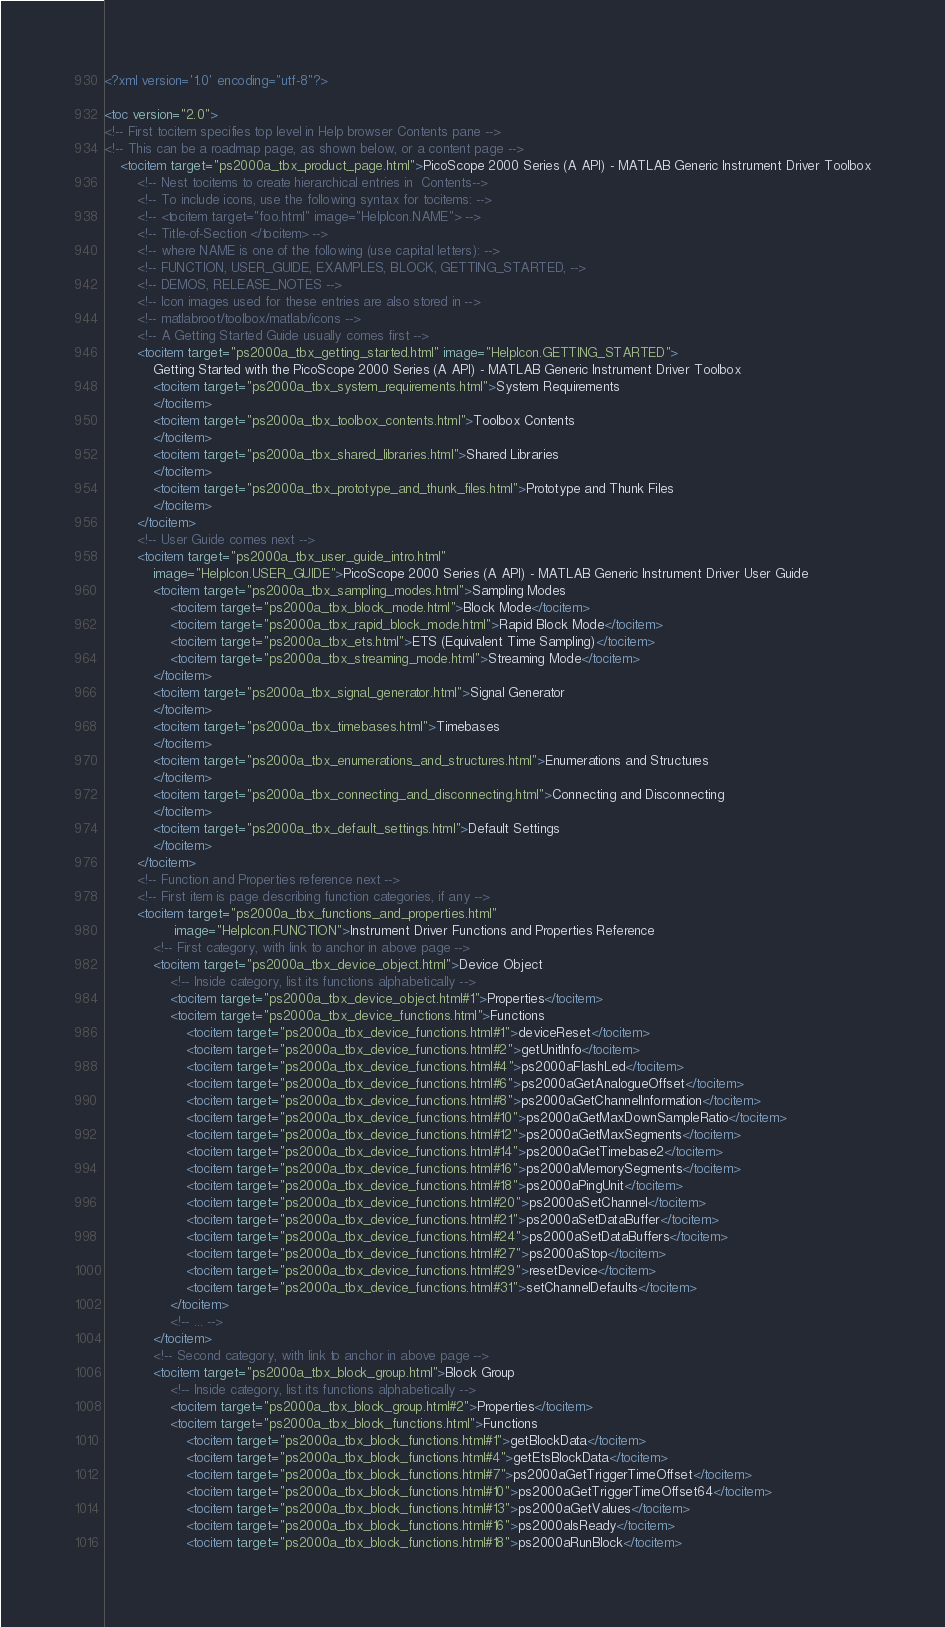Convert code to text. <code><loc_0><loc_0><loc_500><loc_500><_XML_><?xml version='1.0' encoding="utf-8"?>

<toc version="2.0">
<!-- First tocitem specifies top level in Help browser Contents pane -->
<!-- This can be a roadmap page, as shown below, or a content page -->
    <tocitem target="ps2000a_tbx_product_page.html">PicoScope 2000 Series (A API) - MATLAB Generic Instrument Driver Toolbox
        <!-- Nest tocitems to create hierarchical entries in  Contents-->
        <!-- To include icons, use the following syntax for tocitems: -->
        <!-- <tocitem target="foo.html" image="HelpIcon.NAME"> -->
        <!-- Title-of-Section </tocitem> -->
        <!-- where NAME is one of the following (use capital letters): -->
        <!-- FUNCTION, USER_GUIDE, EXAMPLES, BLOCK, GETTING_STARTED, -->
        <!-- DEMOS, RELEASE_NOTES --> 
        <!-- Icon images used for these entries are also stored in -->
        <!-- matlabroot/toolbox/matlab/icons -->
        <!-- A Getting Started Guide usually comes first -->
        <tocitem target="ps2000a_tbx_getting_started.html" image="HelpIcon.GETTING_STARTED">
            Getting Started with the PicoScope 2000 Series (A API) - MATLAB Generic Instrument Driver Toolbox
            <tocitem target="ps2000a_tbx_system_requirements.html">System Requirements
            </tocitem>
            <tocitem target="ps2000a_tbx_toolbox_contents.html">Toolbox Contents
            </tocitem>
            <tocitem target="ps2000a_tbx_shared_libraries.html">Shared Libraries
            </tocitem>
            <tocitem target="ps2000a_tbx_prototype_and_thunk_files.html">Prototype and Thunk Files
            </tocitem>
        </tocitem>
        <!-- User Guide comes next -->
        <tocitem target="ps2000a_tbx_user_guide_intro.html" 
            image="HelpIcon.USER_GUIDE">PicoScope 2000 Series (A API) - MATLAB Generic Instrument Driver User Guide
            <tocitem target="ps2000a_tbx_sampling_modes.html">Sampling Modes
                <tocitem target="ps2000a_tbx_block_mode.html">Block Mode</tocitem>
                <tocitem target="ps2000a_tbx_rapid_block_mode.html">Rapid Block Mode</tocitem>
                <tocitem target="ps2000a_tbx_ets.html">ETS (Equivalent Time Sampling)</tocitem>
                <tocitem target="ps2000a_tbx_streaming_mode.html">Streaming Mode</tocitem>
            </tocitem>
            <tocitem target="ps2000a_tbx_signal_generator.html">Signal Generator
            </tocitem>
            <tocitem target="ps2000a_tbx_timebases.html">Timebases
            </tocitem>
            <tocitem target="ps2000a_tbx_enumerations_and_structures.html">Enumerations and Structures
            </tocitem>
            <tocitem target="ps2000a_tbx_connecting_and_disconnecting.html">Connecting and Disconnecting
            </tocitem>
            <tocitem target="ps2000a_tbx_default_settings.html">Default Settings
            </tocitem>
        </tocitem>
        <!-- Function and Properties reference next -->
        <!-- First item is page describing function categories, if any -->
        <tocitem target="ps2000a_tbx_functions_and_properties.html" 
                 image="HelpIcon.FUNCTION">Instrument Driver Functions and Properties Reference
            <!-- First category, with link to anchor in above page -->
            <tocitem target="ps2000a_tbx_device_object.html">Device Object 
                <!-- Inside category, list its functions alphabetically -->
                <tocitem target="ps2000a_tbx_device_object.html#1">Properties</tocitem>
                <tocitem target="ps2000a_tbx_device_functions.html">Functions
                    <tocitem target="ps2000a_tbx_device_functions.html#1">deviceReset</tocitem>
                    <tocitem target="ps2000a_tbx_device_functions.html#2">getUnitInfo</tocitem>
                    <tocitem target="ps2000a_tbx_device_functions.html#4">ps2000aFlashLed</tocitem>
                    <tocitem target="ps2000a_tbx_device_functions.html#6">ps2000aGetAnalogueOffset</tocitem>
                    <tocitem target="ps2000a_tbx_device_functions.html#8">ps2000aGetChannelInformation</tocitem>
                    <tocitem target="ps2000a_tbx_device_functions.html#10">ps2000aGetMaxDownSampleRatio</tocitem>
                    <tocitem target="ps2000a_tbx_device_functions.html#12">ps2000aGetMaxSegments</tocitem>
                    <tocitem target="ps2000a_tbx_device_functions.html#14">ps2000aGetTimebase2</tocitem>
                    <tocitem target="ps2000a_tbx_device_functions.html#16">ps2000aMemorySegments</tocitem>
                    <tocitem target="ps2000a_tbx_device_functions.html#18">ps2000aPingUnit</tocitem>
                    <tocitem target="ps2000a_tbx_device_functions.html#20">ps2000aSetChannel</tocitem>
                    <tocitem target="ps2000a_tbx_device_functions.html#21">ps2000aSetDataBuffer</tocitem>
                    <tocitem target="ps2000a_tbx_device_functions.html#24">ps2000aSetDataBuffers</tocitem>
                    <tocitem target="ps2000a_tbx_device_functions.html#27">ps2000aStop</tocitem>
                    <tocitem target="ps2000a_tbx_device_functions.html#29">resetDevice</tocitem>
                    <tocitem target="ps2000a_tbx_device_functions.html#31">setChannelDefaults</tocitem>
                </tocitem>
                <!-- ... -->
            </tocitem>
            <!-- Second category, with link to anchor in above page -->
            <tocitem target="ps2000a_tbx_block_group.html">Block Group
                <!-- Inside category, list its functions alphabetically -->
                <tocitem target="ps2000a_tbx_block_group.html#2">Properties</tocitem>
                <tocitem target="ps2000a_tbx_block_functions.html">Functions
                    <tocitem target="ps2000a_tbx_block_functions.html#1">getBlockData</tocitem>
                    <tocitem target="ps2000a_tbx_block_functions.html#4">getEtsBlockData</tocitem>
                    <tocitem target="ps2000a_tbx_block_functions.html#7">ps2000aGetTriggerTimeOffset</tocitem>
                    <tocitem target="ps2000a_tbx_block_functions.html#10">ps2000aGetTriggerTimeOffset64</tocitem>
                    <tocitem target="ps2000a_tbx_block_functions.html#13">ps2000aGetValues</tocitem>
                    <tocitem target="ps2000a_tbx_block_functions.html#16">ps2000aIsReady</tocitem>
                    <tocitem target="ps2000a_tbx_block_functions.html#18">ps2000aRunBlock</tocitem></code> 